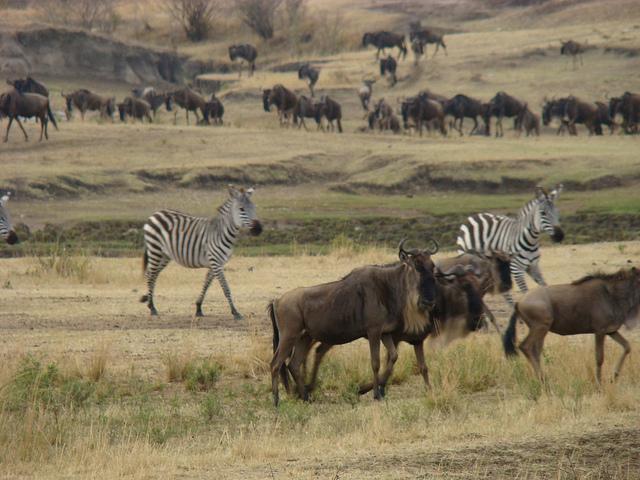How many zebras are visible?
Give a very brief answer. 2. 